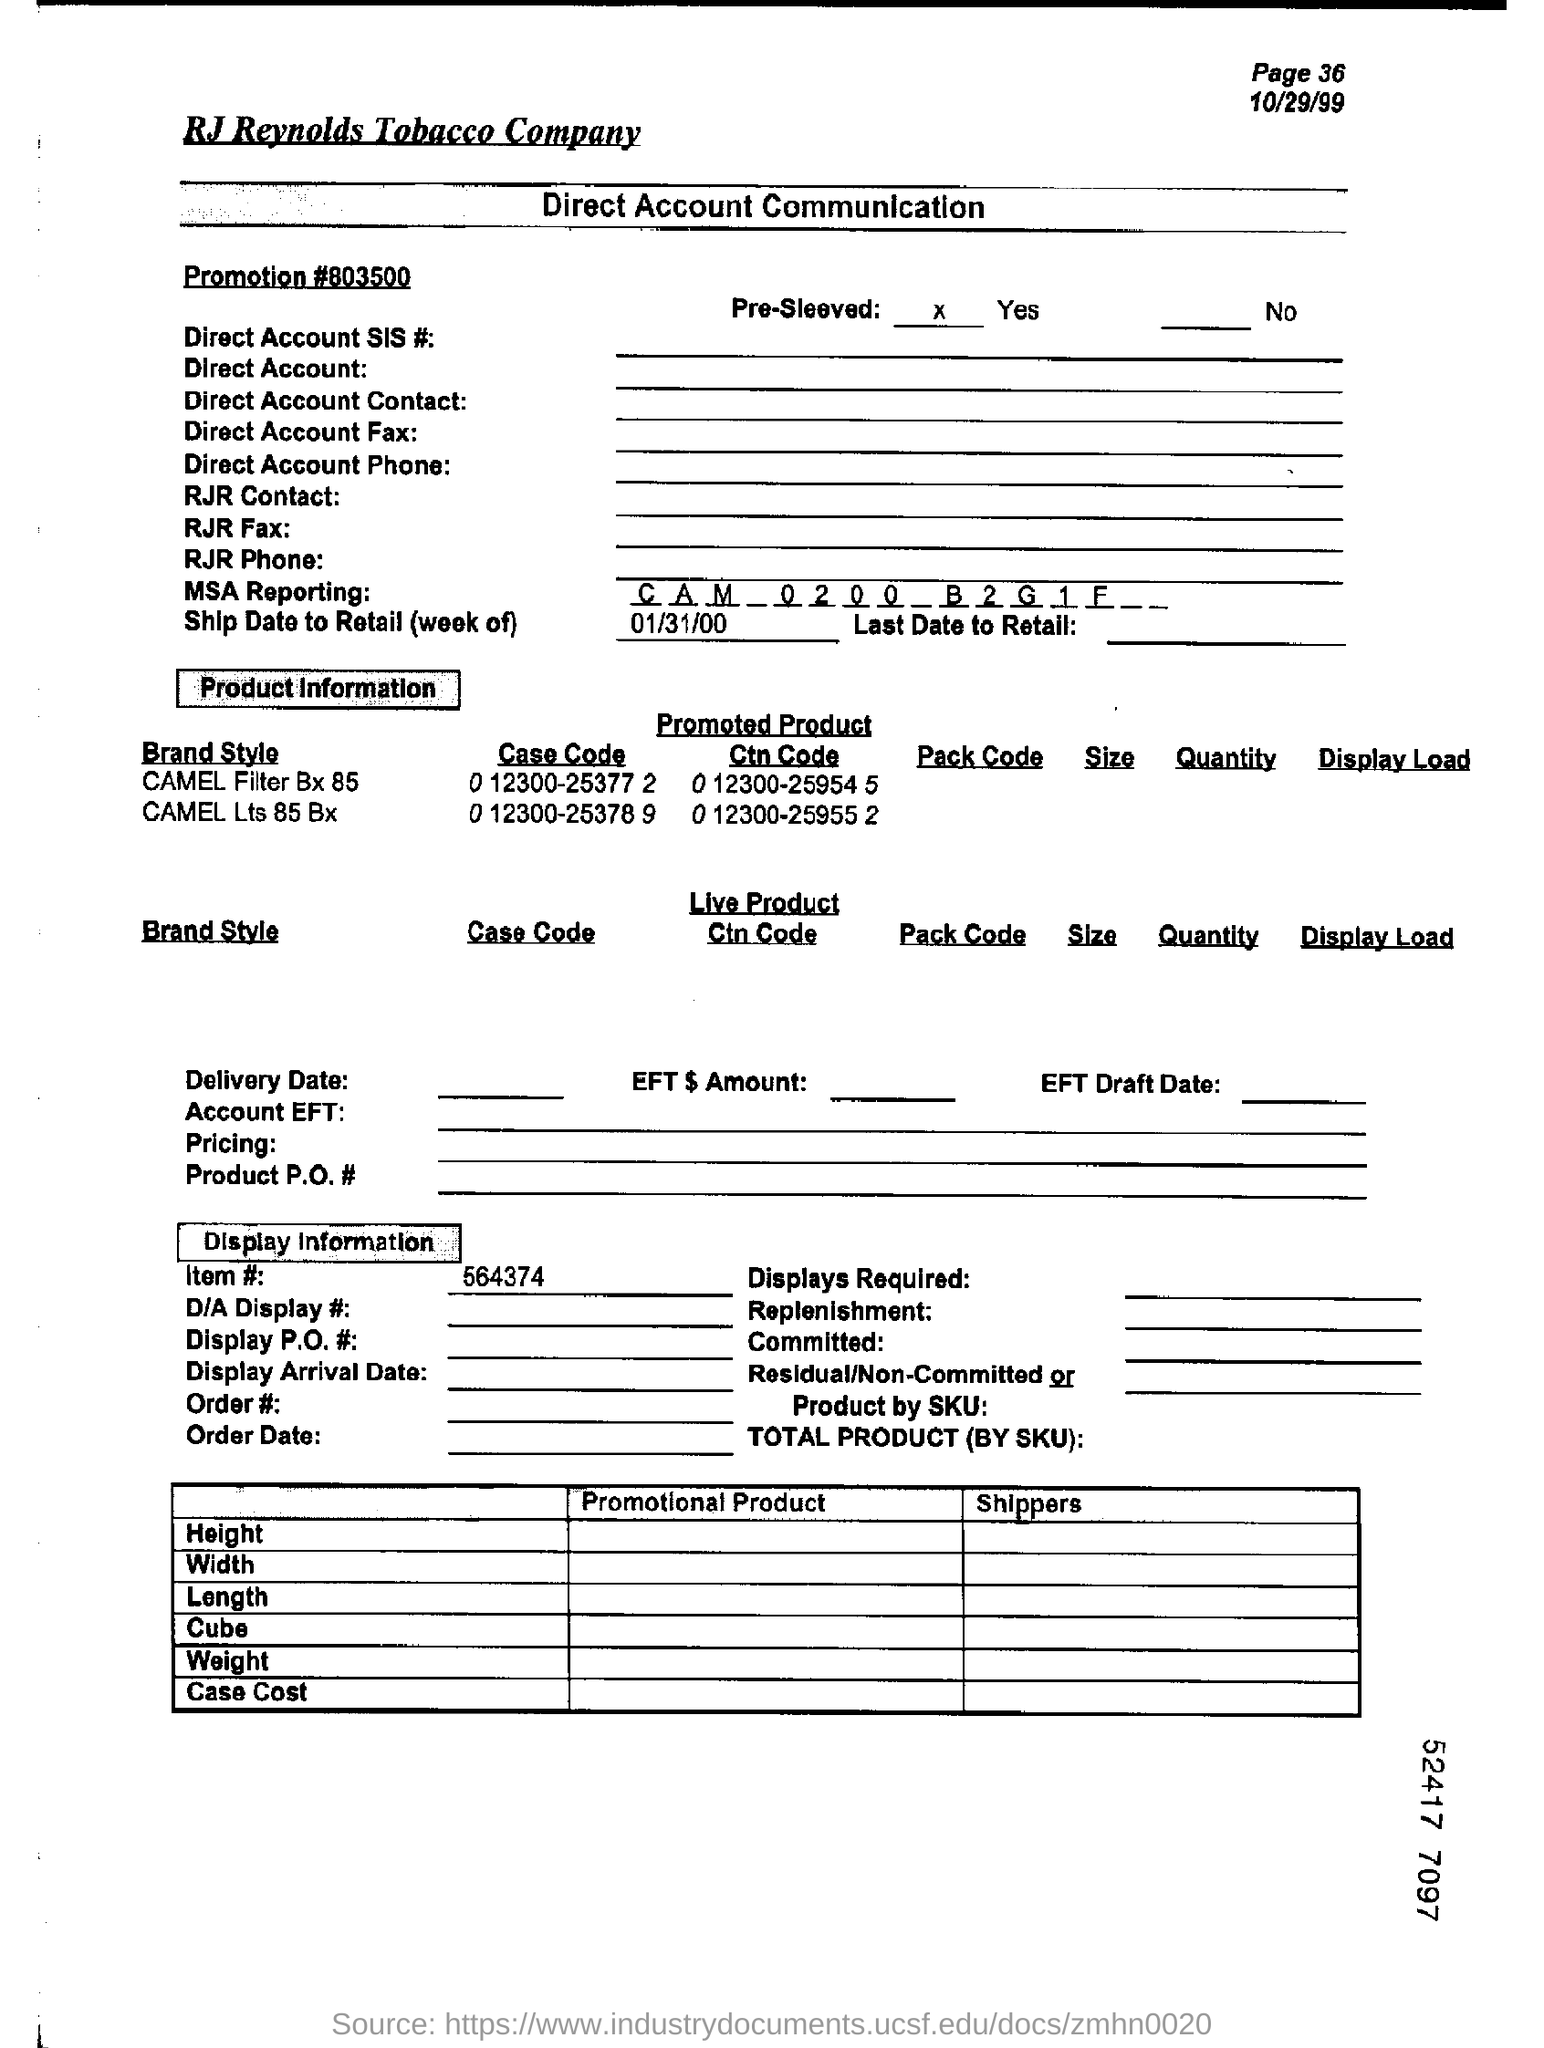What is the MSA Reporting?
Offer a terse response. CAM 0200 B2G1F. What is the Item#?
Your response must be concise. 564374. What is the case code of CAMEL Filter Bx 85?
Give a very brief answer. 0 12300-25377 2. What is the promoted product Ctn Code of CAMEL Lts 85 Bx?
Give a very brief answer. 0 12300-25955 2. What is the page number?
Make the answer very short. 36. 